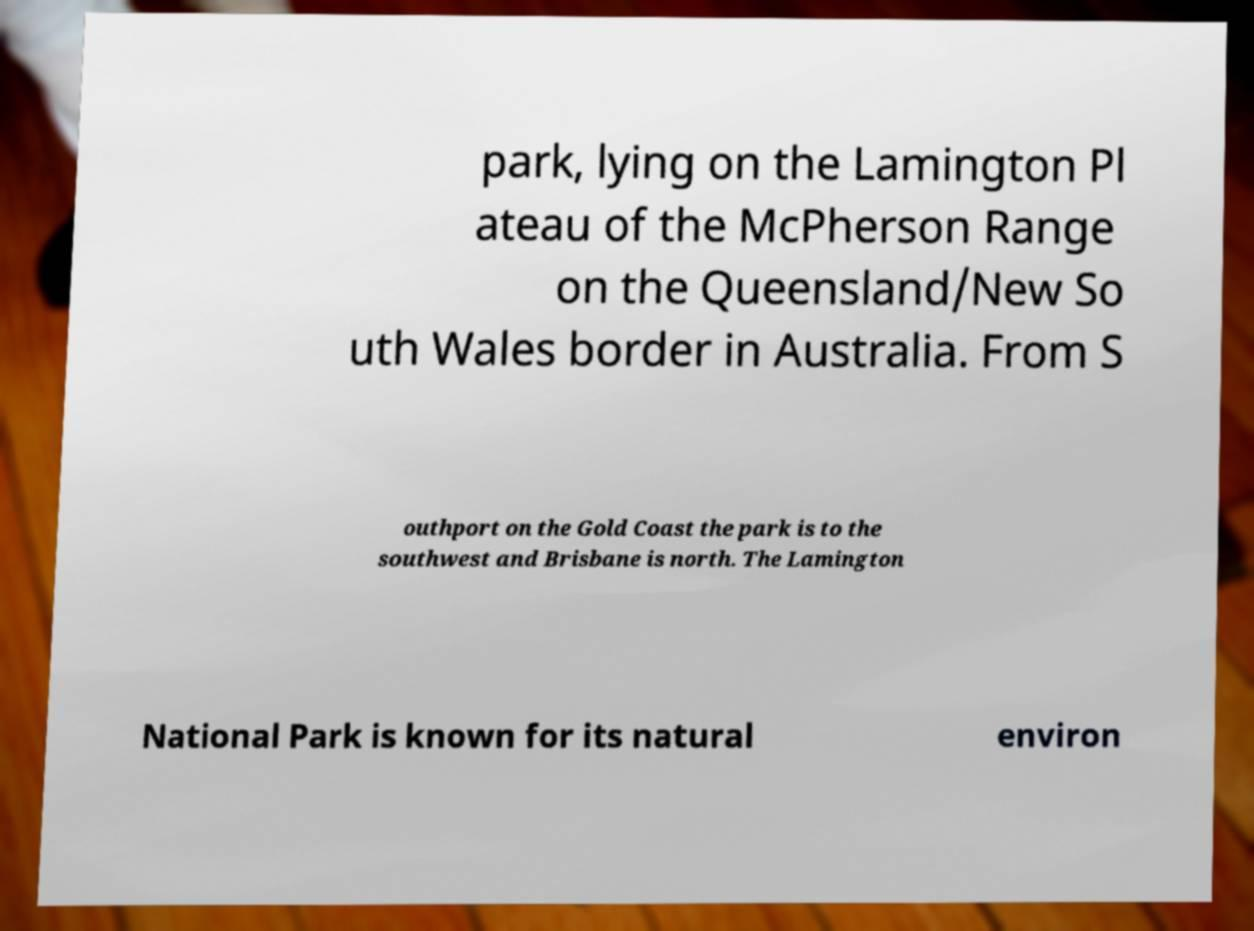For documentation purposes, I need the text within this image transcribed. Could you provide that? park, lying on the Lamington Pl ateau of the McPherson Range on the Queensland/New So uth Wales border in Australia. From S outhport on the Gold Coast the park is to the southwest and Brisbane is north. The Lamington National Park is known for its natural environ 